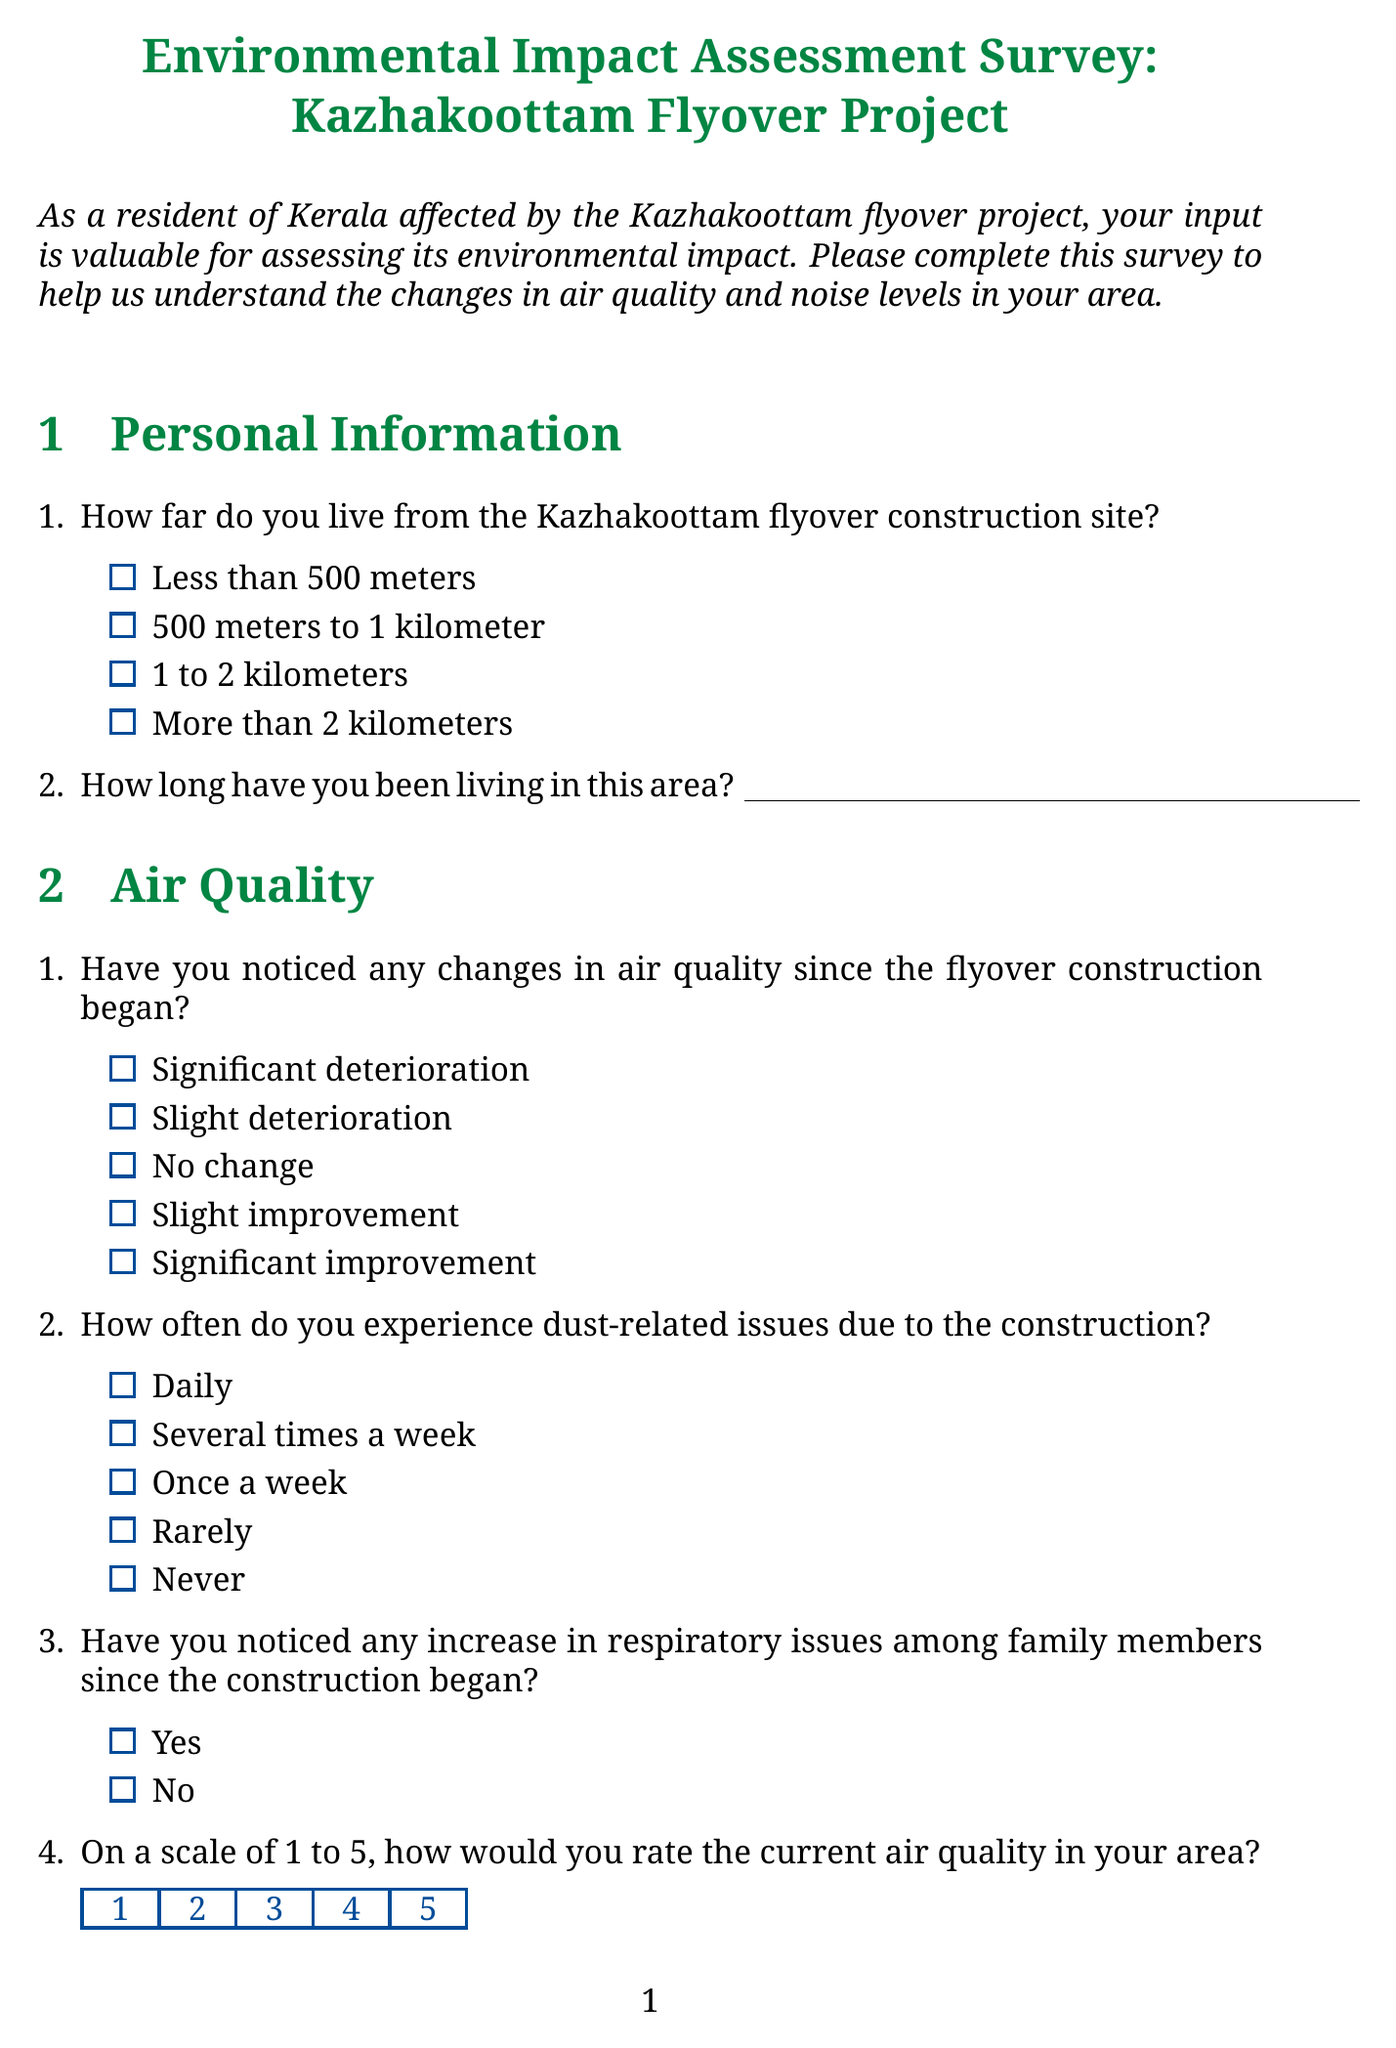What is the title of the survey? The title is provided at the beginning of the document, indicating the purpose of the survey.
Answer: Environmental Impact Assessment Survey: Kazhakoottam Flyover Project How many sections are there in the document? The structure of the document includes multiple distinct sections, each covering a specific topic.
Answer: Six What is one of the options for the distance residents live from the construction site? The document lists several options for the distance question in the Personal Information section.
Answer: Less than 500 meters What is the highest rating scale for air quality in the survey? The survey uses a rating system where respondents can rate their experience from 1 to 5.
Answer: 5 Which water body is mentioned in relation to the construction impact? The document specifically asks about any effects on a local water body.
Answer: Veli-Akkulam Lake What type of measures is suggested for reducing environmental impact? The survey asks about awareness of measures taken and lists potential mitigation strategies.
Answer: None of the above What question assesses the change in noise levels since construction began? The questionnaire includes a specific query regarding noise level changes.
Answer: How has the noise level changed since the flyover construction began? What feedback does the survey seek regarding construction-related sleep issues? A yes/no question addresses the impact of construction noise on sleep patterns.
Answer: Yes or No What is the conclusion of the survey? The end of the document thanks respondents and explains the purpose of their feedback.
Answer: Thank you for completing this survey 